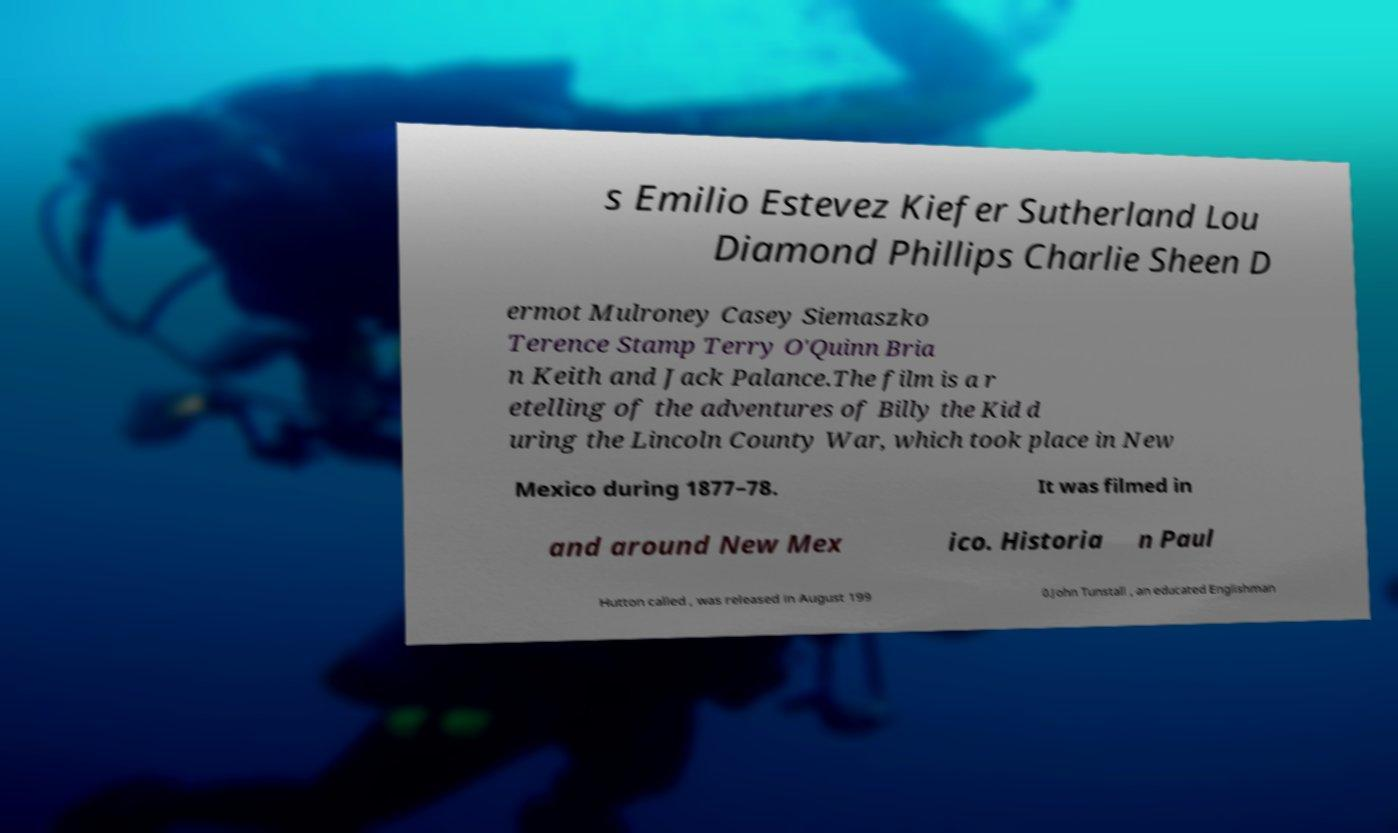Can you accurately transcribe the text from the provided image for me? s Emilio Estevez Kiefer Sutherland Lou Diamond Phillips Charlie Sheen D ermot Mulroney Casey Siemaszko Terence Stamp Terry O'Quinn Bria n Keith and Jack Palance.The film is a r etelling of the adventures of Billy the Kid d uring the Lincoln County War, which took place in New Mexico during 1877–78. It was filmed in and around New Mex ico. Historia n Paul Hutton called , was released in August 199 0.John Tunstall , an educated Englishman 